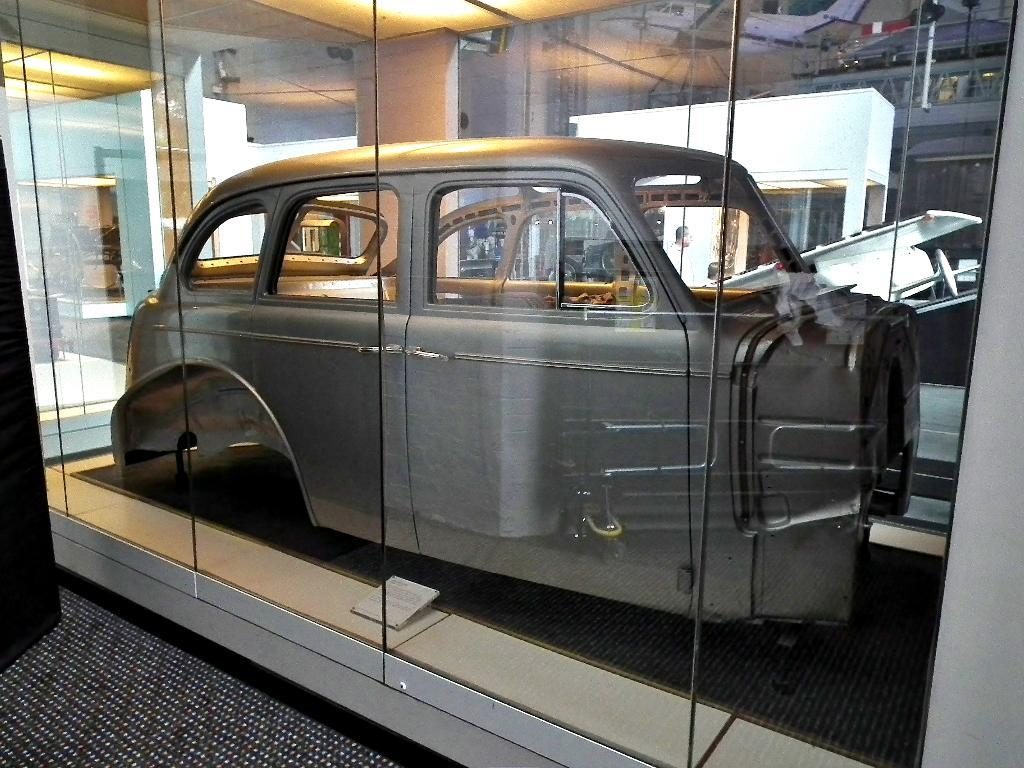What is the main subject of the image? The main subject of the image is a vehicle part. Can you describe the color of the vehicle part? The vehicle part is ash-colored. What is in front of the vehicle part? There is a glass door in front of the vehicle part. What can be seen in the background of the image? There is a building visible at the back side of the image. What type of secretary can be seen working in the image? There is no secretary present in the image; it features a vehicle part, a glass door, and a building in the background. What sound can be heard coming from the vehicle part in the image? There is no sound present in the image, as it is a still image of a vehicle part, a glass door, and a building. 